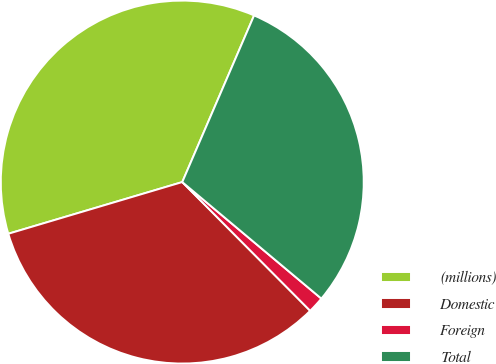Convert chart to OTSL. <chart><loc_0><loc_0><loc_500><loc_500><pie_chart><fcel>(millions)<fcel>Domestic<fcel>Foreign<fcel>Total<nl><fcel>36.07%<fcel>32.85%<fcel>1.45%<fcel>29.62%<nl></chart> 